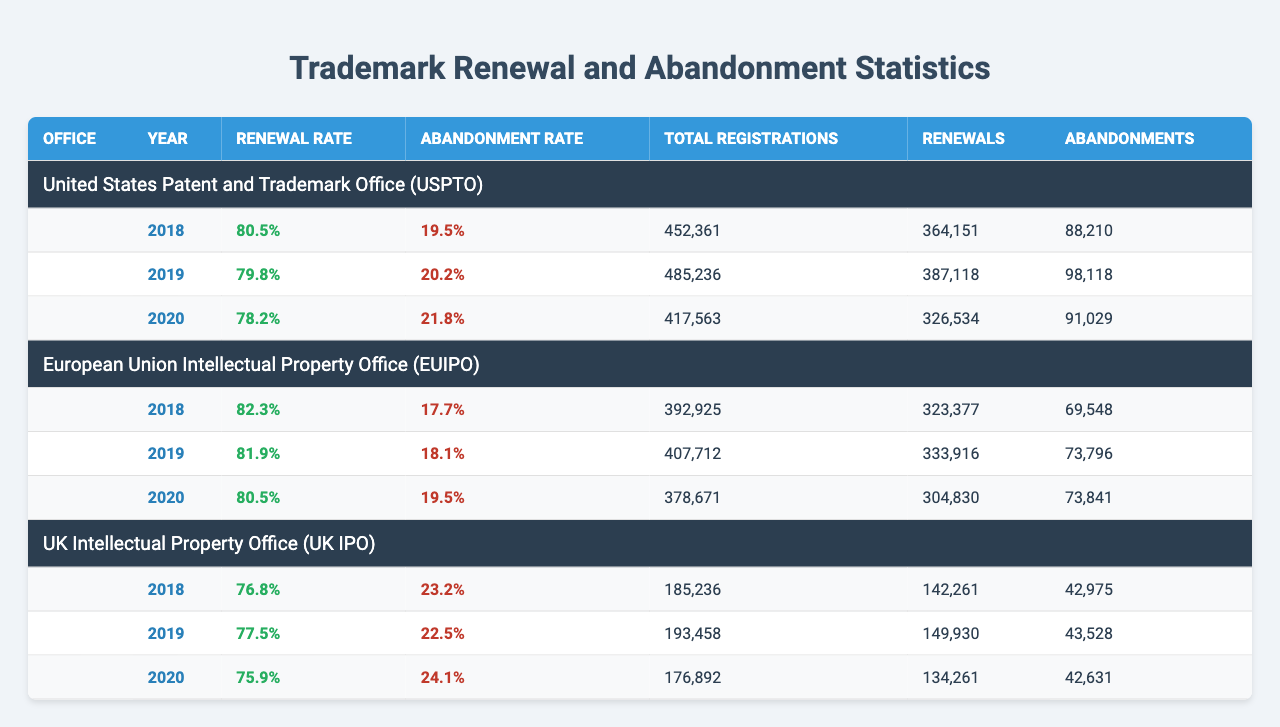What is the renewal rate for trademarks in the USPTO in 2019? The renewal rate for trademarks in the USPTO in 2019 is directly stated in the table. According to the data, it is 79.8%.
Answer: 79.8% What was the total number of trademark renewals in the EUIPO for 2020? The total number of trademark renewals in the EUIPO for 2020 can be found in the corresponding row. The table indicates that there were 304,830 renewals in that year.
Answer: 304,830 Which office had the highest renewal rate in 2018? By comparing the renewal rates for all offices in 2018, the EUIPO had the highest renewal rate at 82.3%.
Answer: EUIPO What is the average abandonment rate across all three trademark offices for the year 2019? First, we find the abandonment rates for all offices in 2019: USPTO (20.2%), EUIPO (18.1%), and UK IPO (22.5%). Then, we calculate the average: (20.2 + 18.1 + 22.5) / 3 = 20.27%.
Answer: 20.27% Did the renewal rate for trademarks in the UK IPO decrease from 2018 to 2020? The renewal rates for the UK IPO in 2018, 2019, and 2020 are 76.8%, 77.5%, and 75.9%, respectively. Since the rate dropped from 77.5% to 75.9% from 2019 to 2020, the answer is yes.
Answer: Yes How many total registrations were abandoned in the USPTO from 2018 to 2020? We first add the number of abandonments for each year in the USPTO: 88,210 (2018) + 98,118 (2019) + 91,029 (2020) = 277,357.
Answer: 277,357 Between which two offices is the difference in renewal rates for 2019 the largest? We compare the renewal rates for 2019: USPTO (79.8%), EUIPO (81.9%), and UK IPO (77.5%). The largest difference is between EUIPO and UK IPO, which is 4.4% (81.9% - 77.5%).
Answer: EUIPO and UK IPO What percentage of registrations were abandoned in the UK IPO for 2019? We can find the abandonment rate for the UK IPO in 2019, which is 22.5%, listed directly next to the UK IPO information in that year’s row.
Answer: 22.5% What is the total number of registrations across all offices in 2020? To find this total, we add the total registrations for all offices in 2020: USPTO (417,563) + EUIPO (378,671) + UK IPO (176,892) = 973,126.
Answer: 973,126 What office had the lowest abandonment rate in 2020? The abandonment rates for 2020 are: USPTO (21.8%), EUIPO (19.5%), and UK IPO (24.1%). The EUIPO has the lowest abandonment rate at 19.5%.
Answer: EUIPO 